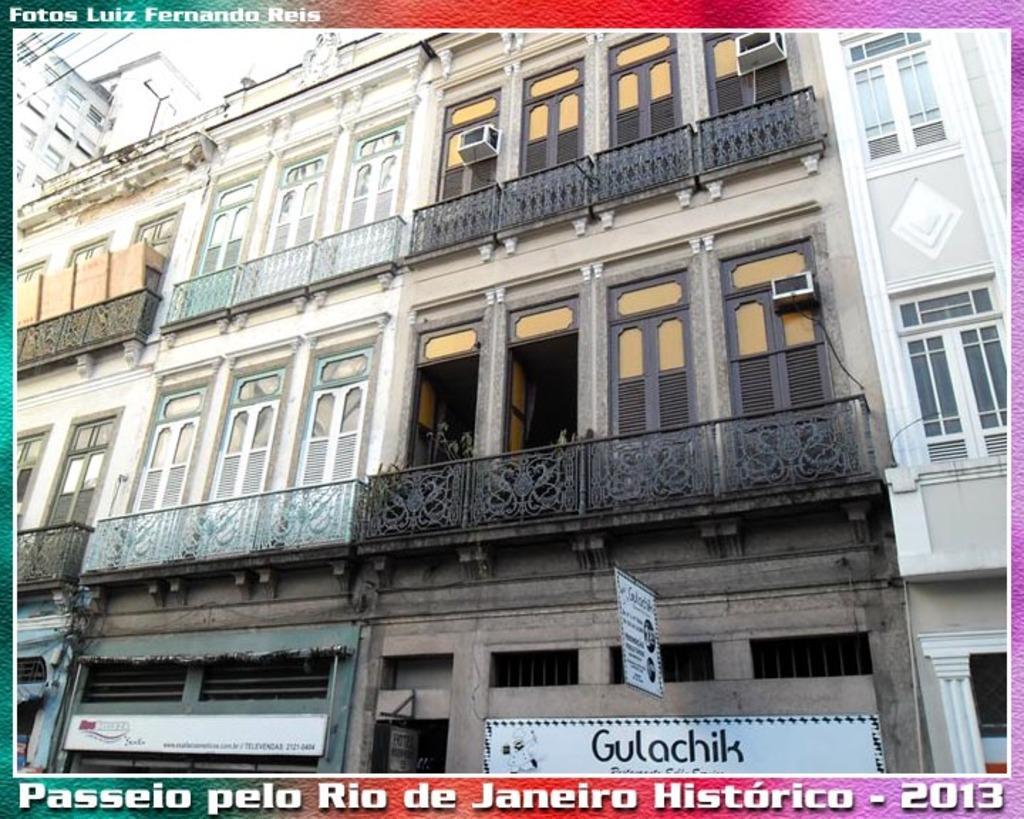Can you describe this image briefly? In the foreground of this image, there are buildings, railings and few boards. 